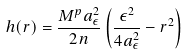<formula> <loc_0><loc_0><loc_500><loc_500>h ( r ) = \frac { M ^ { p } a ^ { 2 } _ { \epsilon } } { 2 n } \left ( \frac { \epsilon ^ { 2 } } { 4 a ^ { 2 } _ { \epsilon } } - r ^ { 2 } \right )</formula> 